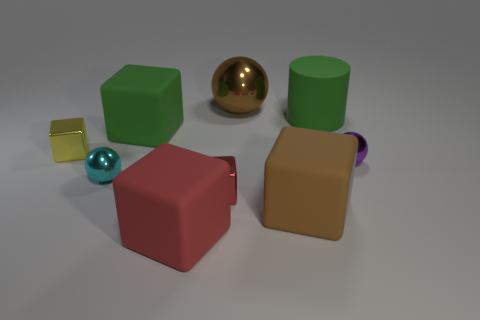How many objects are either big blocks that are behind the tiny purple metallic object or yellow metal cubes?
Offer a very short reply. 2. What shape is the tiny metal object that is left of the tiny sphere left of the green cylinder?
Your answer should be very brief. Cube. Are there any green metallic cylinders of the same size as the green matte cylinder?
Offer a terse response. No. Is the number of brown shiny objects greater than the number of tiny cyan cylinders?
Make the answer very short. Yes. There is a rubber cube that is behind the tiny yellow shiny block; is it the same size as the shiny block that is in front of the tiny yellow object?
Make the answer very short. No. What number of things are on the left side of the brown metallic object and right of the big brown rubber block?
Provide a short and direct response. 0. What color is the other tiny metal object that is the same shape as the small purple thing?
Provide a short and direct response. Cyan. Are there fewer big cyan metallic things than tiny purple objects?
Provide a succinct answer. Yes. There is a cyan thing; is its size the same as the metallic cube that is left of the red rubber cube?
Your answer should be compact. Yes. What is the color of the metal cube left of the big rubber thing in front of the big brown matte block?
Your answer should be very brief. Yellow. 